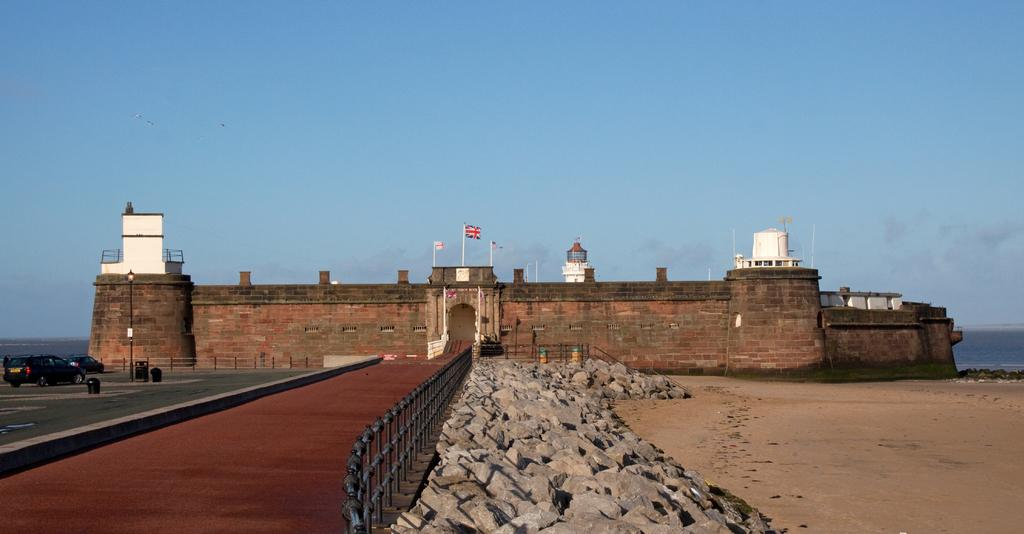What can be seen in the image that represents a symbol or country? There are flags in the image. What type of structures are present at the top of the fort? There are small booths located at the top of the fort. What type of natural elements can be seen in the image? There are stones, sand, and water visible in the image. What type of lighting is present in the image? There is a light on one of the poles in the image. What type of transportation is visible in the image? Vehicles are visible in the image. What type of animals can be seen in the image? Birds are flying in the air in the image. What part of the environment is visible in the image? The sky is visible in the image. Where is the father located in the image? There is no father present in the image. What type of watercraft can be seen in the image? There is no boat present in the image. What type of kitchen appliance can be seen in the image? There is no sink present in the image. 